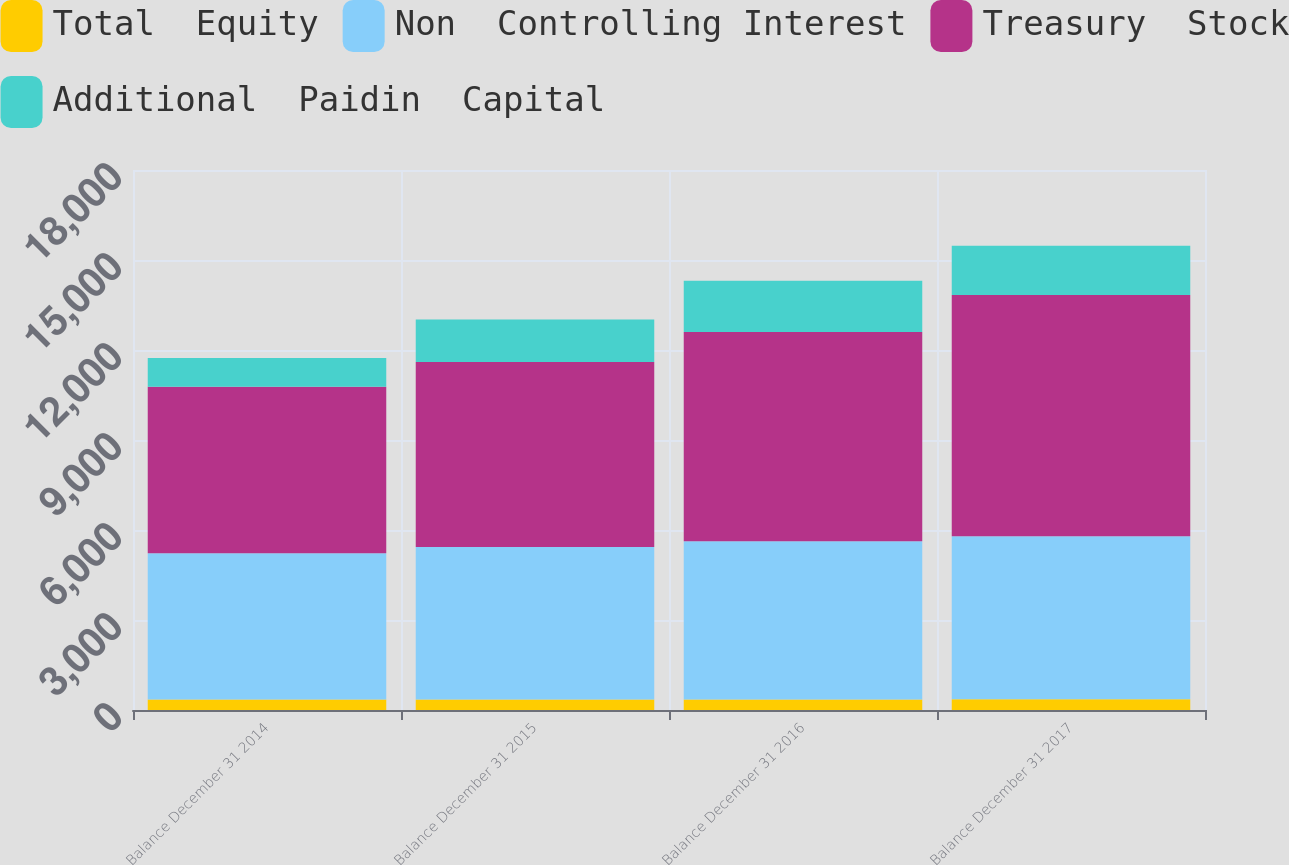<chart> <loc_0><loc_0><loc_500><loc_500><stacked_bar_chart><ecel><fcel>Balance December 31 2014<fcel>Balance December 31 2015<fcel>Balance December 31 2016<fcel>Balance December 31 2017<nl><fcel>Total  Equity<fcel>347.7<fcel>350.3<fcel>352.6<fcel>354.7<nl><fcel>Non  Controlling Interest<fcel>4874.5<fcel>5086.1<fcel>5270.8<fcel>5435.7<nl><fcel>Treasury  Stock<fcel>5555.1<fcel>6160.3<fcel>6975<fcel>8045.4<nl><fcel>Additional  Paidin  Capital<fcel>951.9<fcel>1423.3<fcel>1712.9<fcel>1642.3<nl></chart> 